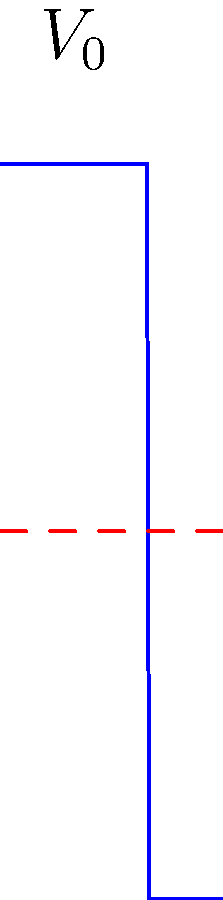Consider a quantum particle with energy $E$ incident on a potential barrier $V(x)$ as shown in the figure. The barrier has a width of $b-a = 2$ units and a height of $V_0 = 10$ units, while the particle's energy is $E = 5$ units. Calculate the transmission coefficient $T$ for this system, given that the particle's mass $m$ and $\hbar$ are both unity. How does this result demonstrate the quantum tunneling effect? To solve this problem, we'll follow these steps:

1) First, we need to identify the wave numbers in each region:
   Region I and III (outside the barrier): $k = \sqrt{2mE/\hbar^2} = \sqrt{2 \cdot 1 \cdot 5 / 1^2} = \sqrt{10}$
   Region II (inside the barrier): $\kappa = \sqrt{2m(V_0-E)/\hbar^2} = \sqrt{2 \cdot 1 \cdot 5 / 1^2} = \sqrt{10}$

2) The transmission coefficient for a rectangular barrier is given by:

   $T = \left[1 + \frac{V_0^2}{4E(V_0-E)} \sinh^2(\kappa(b-a))\right]^{-1}$

3) Substituting our values:
   $T = \left[1 + \frac{10^2}{4 \cdot 5 \cdot 5} \sinh^2(\sqrt{10} \cdot 2)\right]^{-1}$

4) Calculating:
   $T \approx 0.0165$ or about 1.65%

5) This result demonstrates quantum tunneling because despite the particle's energy being less than the barrier height (classically forbidden), there's still a non-zero probability of transmission through the barrier. In classical mechanics, this probability would be exactly zero.

6) The low transmission coefficient is due to the barrier being relatively wide and high compared to the particle's energy, but it's still not zero, which is a key feature of quantum tunneling.
Answer: $T \approx 0.0165$ (1.65% transmission), demonstrating quantum tunneling through a classically forbidden region. 